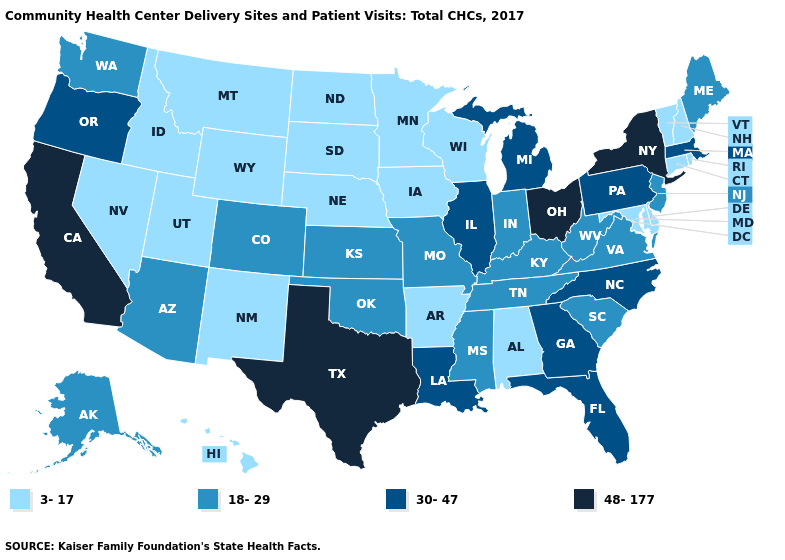Among the states that border New Jersey , does New York have the highest value?
Short answer required. Yes. How many symbols are there in the legend?
Give a very brief answer. 4. Name the states that have a value in the range 3-17?
Write a very short answer. Alabama, Arkansas, Connecticut, Delaware, Hawaii, Idaho, Iowa, Maryland, Minnesota, Montana, Nebraska, Nevada, New Hampshire, New Mexico, North Dakota, Rhode Island, South Dakota, Utah, Vermont, Wisconsin, Wyoming. Name the states that have a value in the range 3-17?
Write a very short answer. Alabama, Arkansas, Connecticut, Delaware, Hawaii, Idaho, Iowa, Maryland, Minnesota, Montana, Nebraska, Nevada, New Hampshire, New Mexico, North Dakota, Rhode Island, South Dakota, Utah, Vermont, Wisconsin, Wyoming. Name the states that have a value in the range 18-29?
Be succinct. Alaska, Arizona, Colorado, Indiana, Kansas, Kentucky, Maine, Mississippi, Missouri, New Jersey, Oklahoma, South Carolina, Tennessee, Virginia, Washington, West Virginia. What is the value of South Carolina?
Answer briefly. 18-29. Among the states that border Illinois , which have the highest value?
Keep it brief. Indiana, Kentucky, Missouri. Name the states that have a value in the range 48-177?
Answer briefly. California, New York, Ohio, Texas. What is the lowest value in states that border Pennsylvania?
Concise answer only. 3-17. What is the value of South Dakota?
Short answer required. 3-17. Does Nevada have the highest value in the USA?
Be succinct. No. Name the states that have a value in the range 30-47?
Keep it brief. Florida, Georgia, Illinois, Louisiana, Massachusetts, Michigan, North Carolina, Oregon, Pennsylvania. What is the value of Nebraska?
Give a very brief answer. 3-17. What is the lowest value in states that border California?
Write a very short answer. 3-17. Name the states that have a value in the range 30-47?
Be succinct. Florida, Georgia, Illinois, Louisiana, Massachusetts, Michigan, North Carolina, Oregon, Pennsylvania. 